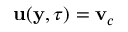Convert formula to latex. <formula><loc_0><loc_0><loc_500><loc_500>{ \mathbf u } ( { \mathbf y } , \tau ) = { \mathbf v } _ { c }</formula> 